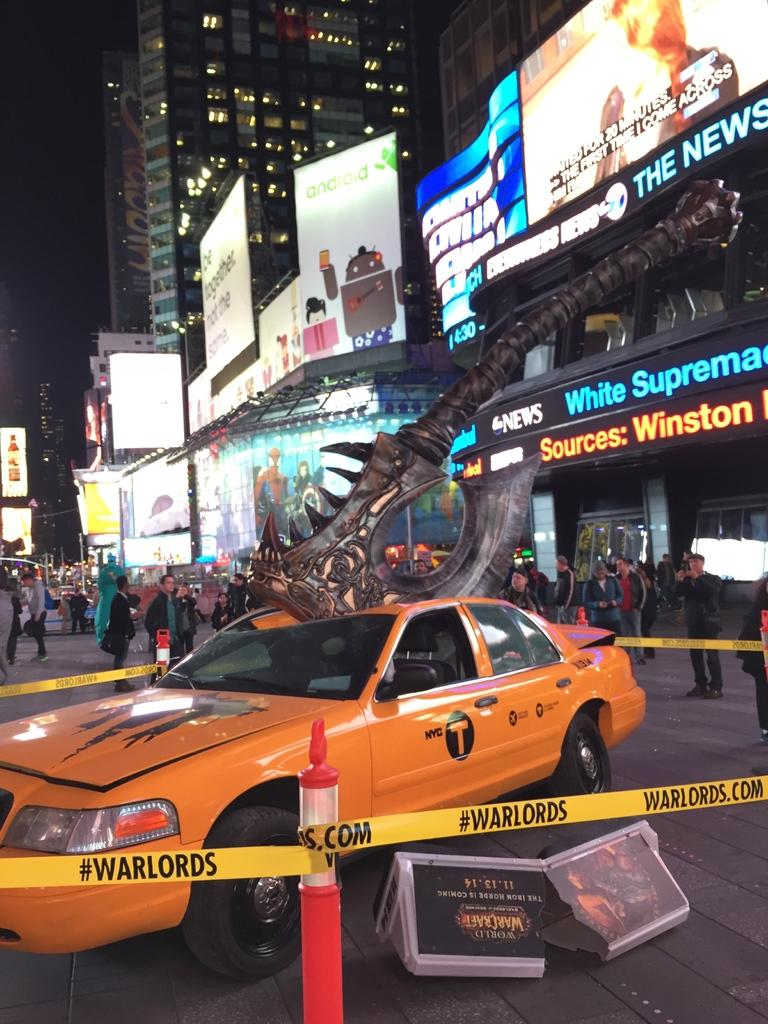<image>
Share a concise interpretation of the image provided. An orange taxi is on display with a giant axe stuck in the roof and is cordoned off with tape that has #warlords on it. 